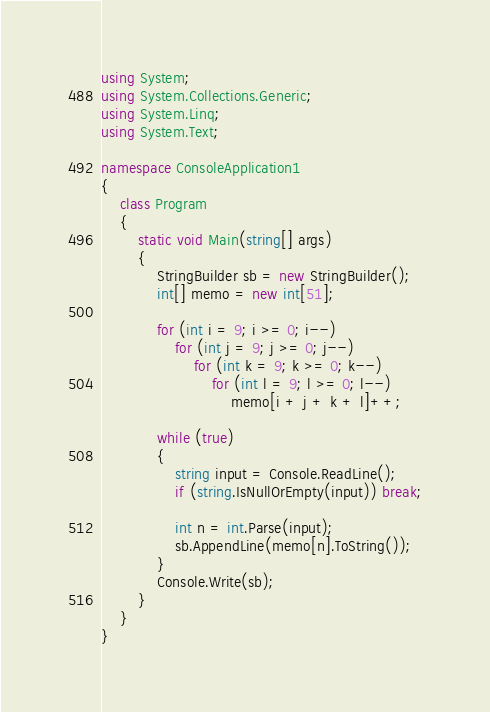<code> <loc_0><loc_0><loc_500><loc_500><_C#_>using System;
using System.Collections.Generic;
using System.Linq;
using System.Text;

namespace ConsoleApplication1
{
    class Program
    {
        static void Main(string[] args)
        {
            StringBuilder sb = new StringBuilder();
            int[] memo = new int[51];

            for (int i = 9; i >= 0; i--)
                for (int j = 9; j >= 0; j--)
                    for (int k = 9; k >= 0; k--)
                        for (int l = 9; l >= 0; l--)
                            memo[i + j + k + l]++;

            while (true)
            {
                string input = Console.ReadLine();
                if (string.IsNullOrEmpty(input)) break;

                int n = int.Parse(input);
                sb.AppendLine(memo[n].ToString());
            }
            Console.Write(sb);
        }
    }
}</code> 